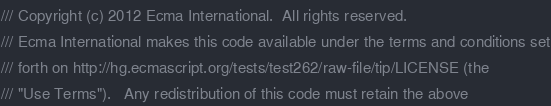Convert code to text. <code><loc_0><loc_0><loc_500><loc_500><_JavaScript_>/// Copyright (c) 2012 Ecma International.  All rights reserved. 
/// Ecma International makes this code available under the terms and conditions set
/// forth on http://hg.ecmascript.org/tests/test262/raw-file/tip/LICENSE (the 
/// "Use Terms").   Any redistribution of this code must retain the above </code> 